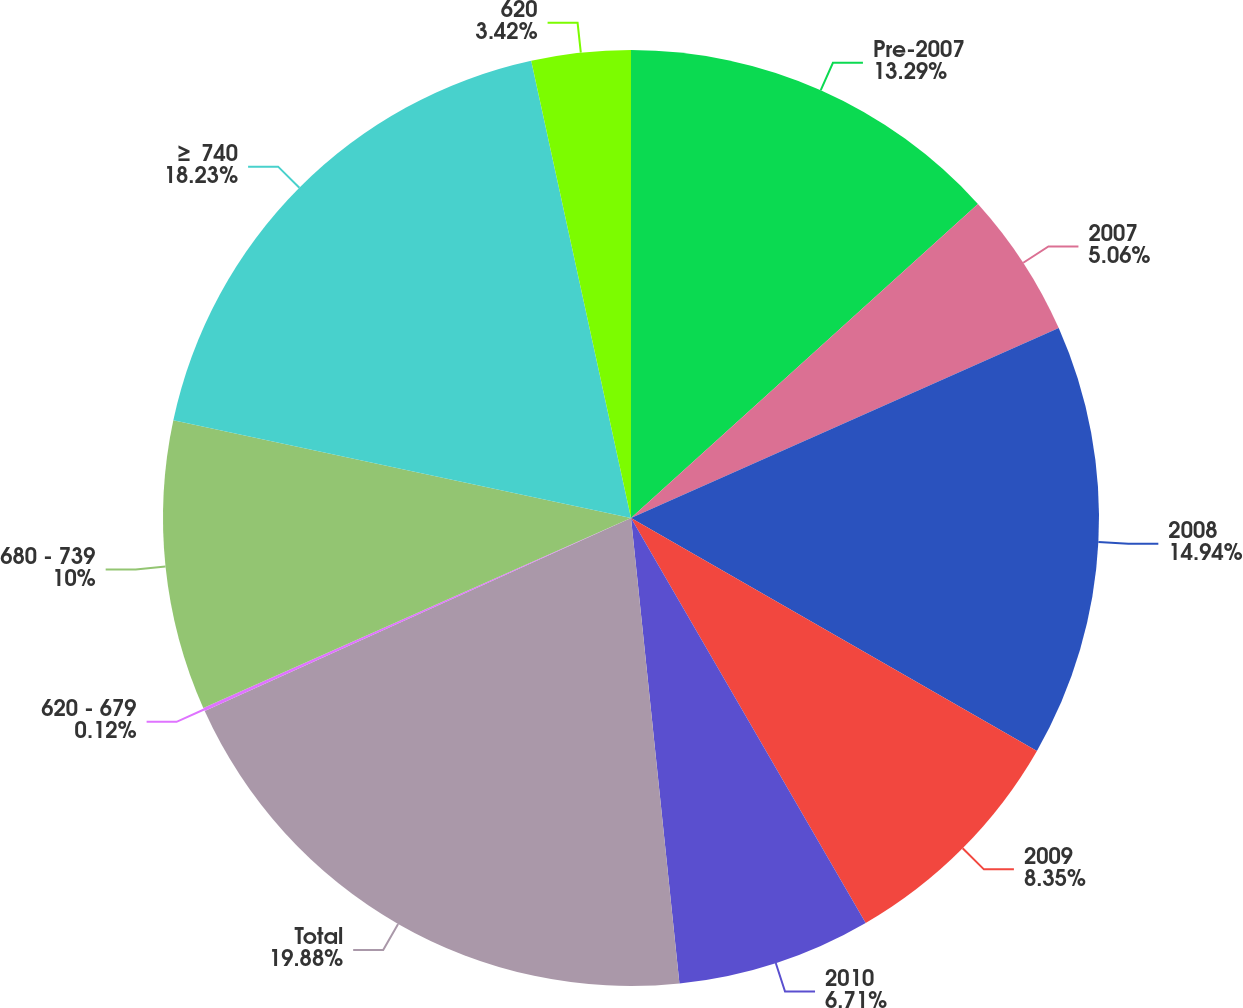<chart> <loc_0><loc_0><loc_500><loc_500><pie_chart><fcel>Pre-2007<fcel>2007<fcel>2008<fcel>2009<fcel>2010<fcel>Total<fcel>620 - 679<fcel>680 - 739<fcel>≥ 740<fcel>620<nl><fcel>13.29%<fcel>5.06%<fcel>14.94%<fcel>8.35%<fcel>6.71%<fcel>19.88%<fcel>0.12%<fcel>10.0%<fcel>18.23%<fcel>3.42%<nl></chart> 